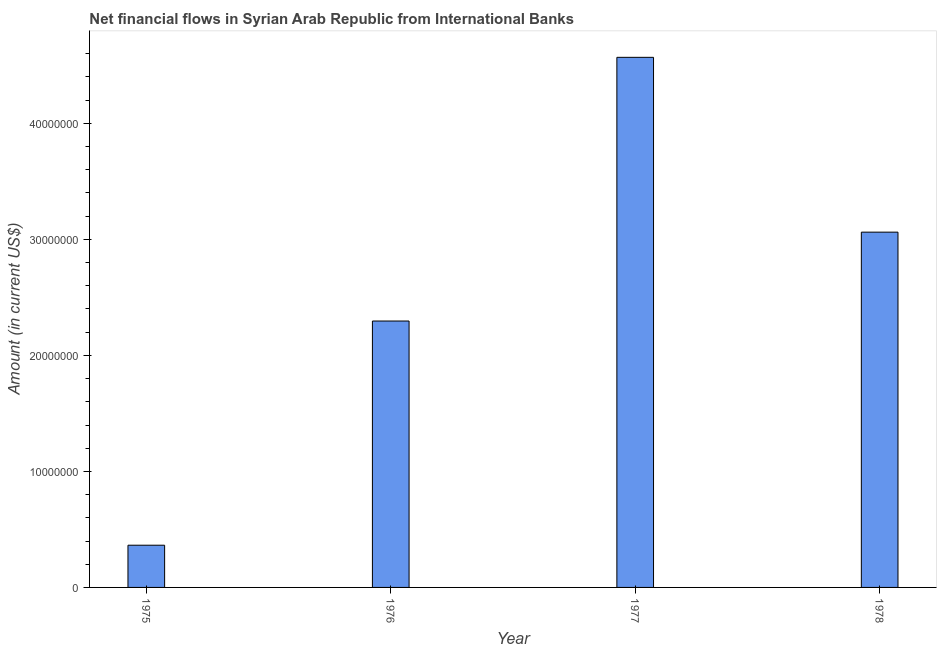What is the title of the graph?
Keep it short and to the point. Net financial flows in Syrian Arab Republic from International Banks. What is the net financial flows from ibrd in 1976?
Provide a succinct answer. 2.30e+07. Across all years, what is the maximum net financial flows from ibrd?
Give a very brief answer. 4.57e+07. Across all years, what is the minimum net financial flows from ibrd?
Your response must be concise. 3.64e+06. In which year was the net financial flows from ibrd minimum?
Offer a very short reply. 1975. What is the sum of the net financial flows from ibrd?
Provide a succinct answer. 1.03e+08. What is the difference between the net financial flows from ibrd in 1977 and 1978?
Provide a short and direct response. 1.51e+07. What is the average net financial flows from ibrd per year?
Your answer should be compact. 2.57e+07. What is the median net financial flows from ibrd?
Give a very brief answer. 2.68e+07. Do a majority of the years between 1977 and 1976 (inclusive) have net financial flows from ibrd greater than 4000000 US$?
Offer a very short reply. No. What is the ratio of the net financial flows from ibrd in 1976 to that in 1977?
Give a very brief answer. 0.5. Is the net financial flows from ibrd in 1976 less than that in 1978?
Your answer should be very brief. Yes. What is the difference between the highest and the second highest net financial flows from ibrd?
Give a very brief answer. 1.51e+07. Is the sum of the net financial flows from ibrd in 1976 and 1978 greater than the maximum net financial flows from ibrd across all years?
Make the answer very short. Yes. What is the difference between the highest and the lowest net financial flows from ibrd?
Provide a succinct answer. 4.21e+07. In how many years, is the net financial flows from ibrd greater than the average net financial flows from ibrd taken over all years?
Your answer should be compact. 2. How many years are there in the graph?
Provide a succinct answer. 4. What is the difference between two consecutive major ticks on the Y-axis?
Make the answer very short. 1.00e+07. What is the Amount (in current US$) in 1975?
Offer a terse response. 3.64e+06. What is the Amount (in current US$) in 1976?
Offer a terse response. 2.30e+07. What is the Amount (in current US$) of 1977?
Give a very brief answer. 4.57e+07. What is the Amount (in current US$) in 1978?
Provide a short and direct response. 3.06e+07. What is the difference between the Amount (in current US$) in 1975 and 1976?
Your answer should be very brief. -1.93e+07. What is the difference between the Amount (in current US$) in 1975 and 1977?
Provide a short and direct response. -4.21e+07. What is the difference between the Amount (in current US$) in 1975 and 1978?
Make the answer very short. -2.70e+07. What is the difference between the Amount (in current US$) in 1976 and 1977?
Your response must be concise. -2.27e+07. What is the difference between the Amount (in current US$) in 1976 and 1978?
Make the answer very short. -7.66e+06. What is the difference between the Amount (in current US$) in 1977 and 1978?
Keep it short and to the point. 1.51e+07. What is the ratio of the Amount (in current US$) in 1975 to that in 1976?
Your answer should be compact. 0.16. What is the ratio of the Amount (in current US$) in 1975 to that in 1978?
Provide a succinct answer. 0.12. What is the ratio of the Amount (in current US$) in 1976 to that in 1977?
Ensure brevity in your answer.  0.5. What is the ratio of the Amount (in current US$) in 1977 to that in 1978?
Give a very brief answer. 1.49. 